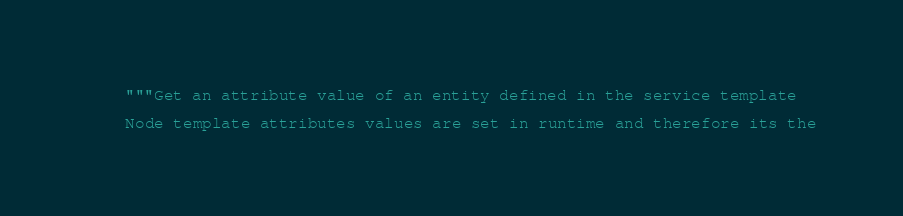Convert code to text. <code><loc_0><loc_0><loc_500><loc_500><_Python_>    """Get an attribute value of an entity defined in the service template

    Node template attributes values are set in runtime and therefore its the</code> 